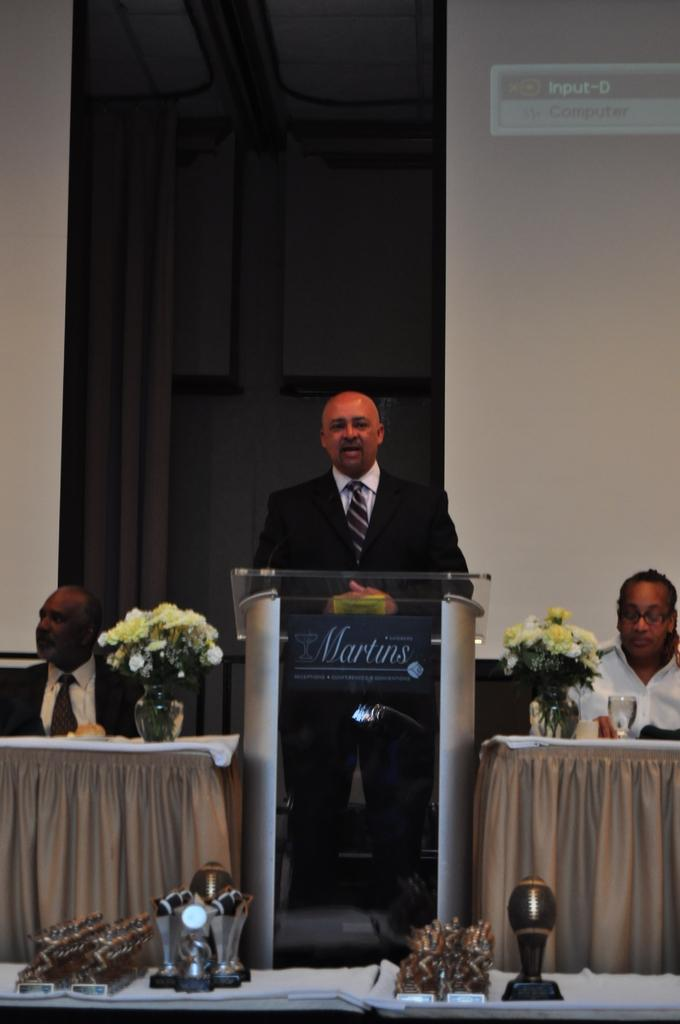What is the man at the front of the image doing? The man is standing and speaking at a podium. Who is present on either side of the speaker? There are two men sitting at a table on either side of the speaker. What can be seen beside the men at the table? There are two flower bouquets beside the men at the table. What type of whip is being used by the speaker in the image? There is no whip present in the image; the speaker is using a microphone or speaking without any additional tools. 